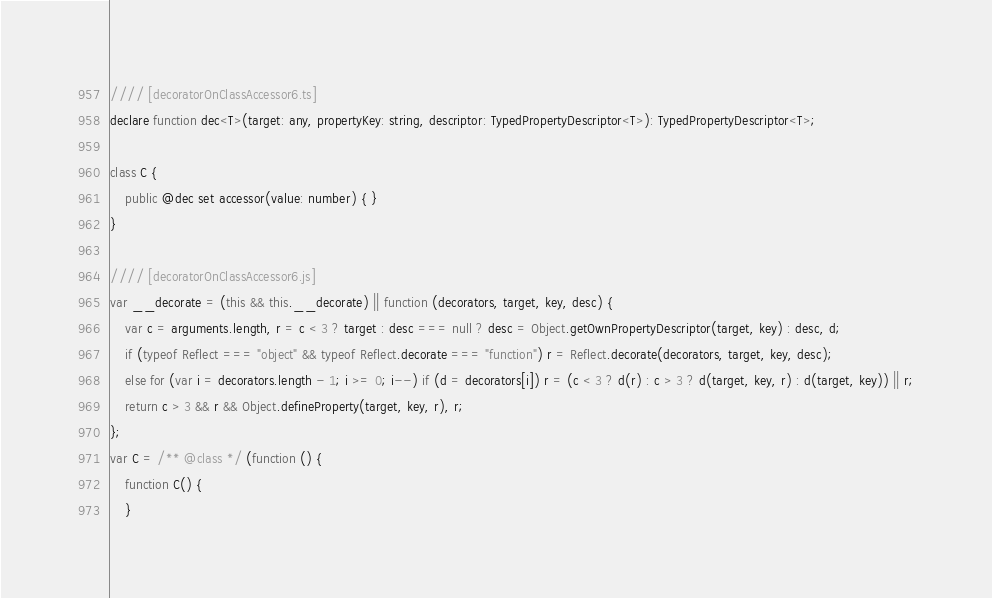Convert code to text. <code><loc_0><loc_0><loc_500><loc_500><_JavaScript_>//// [decoratorOnClassAccessor6.ts]
declare function dec<T>(target: any, propertyKey: string, descriptor: TypedPropertyDescriptor<T>): TypedPropertyDescriptor<T>;

class C {
    public @dec set accessor(value: number) { }
}

//// [decoratorOnClassAccessor6.js]
var __decorate = (this && this.__decorate) || function (decorators, target, key, desc) {
    var c = arguments.length, r = c < 3 ? target : desc === null ? desc = Object.getOwnPropertyDescriptor(target, key) : desc, d;
    if (typeof Reflect === "object" && typeof Reflect.decorate === "function") r = Reflect.decorate(decorators, target, key, desc);
    else for (var i = decorators.length - 1; i >= 0; i--) if (d = decorators[i]) r = (c < 3 ? d(r) : c > 3 ? d(target, key, r) : d(target, key)) || r;
    return c > 3 && r && Object.defineProperty(target, key, r), r;
};
var C = /** @class */ (function () {
    function C() {
    }</code> 